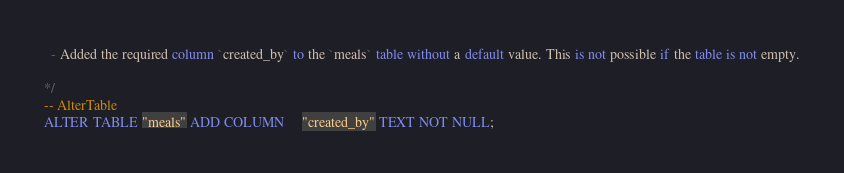Convert code to text. <code><loc_0><loc_0><loc_500><loc_500><_SQL_>
  - Added the required column `created_by` to the `meals` table without a default value. This is not possible if the table is not empty.

*/
-- AlterTable
ALTER TABLE "meals" ADD COLUMN     "created_by" TEXT NOT NULL;
</code> 